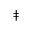Convert formula to latex. <formula><loc_0><loc_0><loc_500><loc_500>\ddag</formula> 